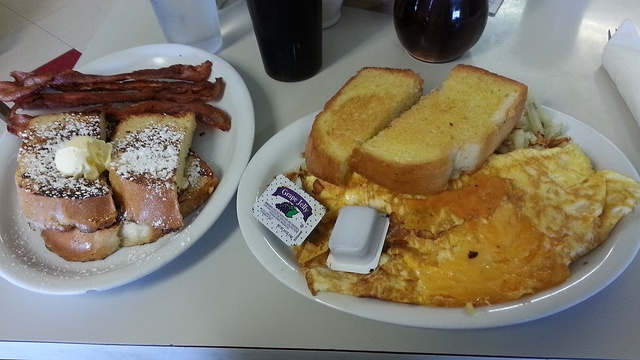Describe the objects in this image and their specific colors. I can see dining table in darkgray, gray, olive, and black tones, bowl in gray, olive, darkgray, and maroon tones, bowl in gray, darkgray, and lightgray tones, sandwich in gray, olive, and maroon tones, and sandwich in gray, darkgray, tan, and lightgray tones in this image. 